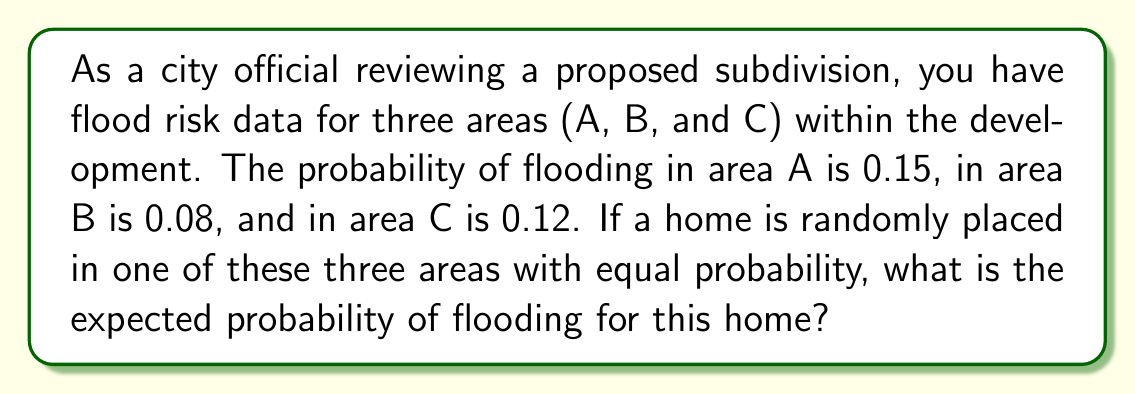Give your solution to this math problem. To solve this problem, we need to use the concept of expected value in probability theory. Here's a step-by-step explanation:

1) First, let's define our events and their probabilities:
   - P(A) = Probability of the home being in area A = 1/3
   - P(B) = Probability of the home being in area B = 1/3
   - P(C) = Probability of the home being in area C = 1/3
   - P(F|A) = Probability of flooding given the home is in area A = 0.15
   - P(F|B) = Probability of flooding given the home is in area B = 0.08
   - P(F|C) = Probability of flooding given the home is in area C = 0.12

2) The expected probability of flooding is the sum of the probabilities of flooding in each area, weighted by the probability of the home being in that area. We can express this mathematically as:

   $$E(P(F)) = P(A) \cdot P(F|A) + P(B) \cdot P(F|B) + P(C) \cdot P(F|C)$$

3) Now, let's substitute the values:

   $$E(P(F)) = \frac{1}{3} \cdot 0.15 + \frac{1}{3} \cdot 0.08 + \frac{1}{3} \cdot 0.12$$

4) Simplify:

   $$E(P(F)) = \frac{0.15 + 0.08 + 0.12}{3} = \frac{0.35}{3}$$

5) Calculate the final result:

   $$E(P(F)) = \frac{0.35}{3} \approx 0.1167$$

Therefore, the expected probability of flooding for a randomly placed home in this subdivision is approximately 0.1167 or 11.67%.
Answer: The expected probability of flooding for a randomly placed home in the proposed subdivision is approximately 0.1167 or 11.67%. 